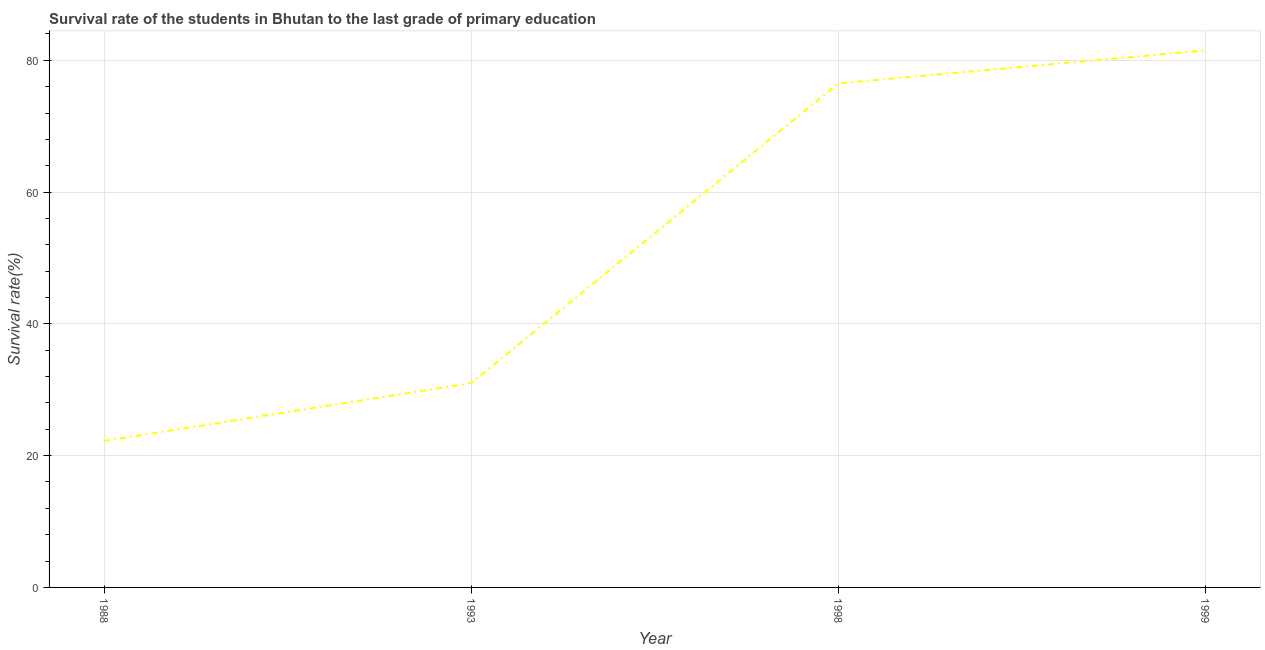What is the survival rate in primary education in 1993?
Your answer should be very brief. 31.02. Across all years, what is the maximum survival rate in primary education?
Your response must be concise. 81.51. Across all years, what is the minimum survival rate in primary education?
Give a very brief answer. 22.22. What is the sum of the survival rate in primary education?
Provide a succinct answer. 211.24. What is the difference between the survival rate in primary education in 1988 and 1998?
Your answer should be very brief. -54.27. What is the average survival rate in primary education per year?
Offer a terse response. 52.81. What is the median survival rate in primary education?
Offer a very short reply. 53.76. In how many years, is the survival rate in primary education greater than 28 %?
Keep it short and to the point. 3. What is the ratio of the survival rate in primary education in 1998 to that in 1999?
Your response must be concise. 0.94. Is the survival rate in primary education in 1988 less than that in 1993?
Offer a terse response. Yes. What is the difference between the highest and the second highest survival rate in primary education?
Provide a succinct answer. 5.01. What is the difference between the highest and the lowest survival rate in primary education?
Offer a very short reply. 59.28. How many lines are there?
Offer a terse response. 1. How many years are there in the graph?
Your answer should be very brief. 4. Are the values on the major ticks of Y-axis written in scientific E-notation?
Make the answer very short. No. Does the graph contain grids?
Provide a succinct answer. Yes. What is the title of the graph?
Provide a short and direct response. Survival rate of the students in Bhutan to the last grade of primary education. What is the label or title of the Y-axis?
Your response must be concise. Survival rate(%). What is the Survival rate(%) of 1988?
Make the answer very short. 22.22. What is the Survival rate(%) in 1993?
Your answer should be very brief. 31.02. What is the Survival rate(%) in 1998?
Your answer should be compact. 76.49. What is the Survival rate(%) in 1999?
Your answer should be very brief. 81.51. What is the difference between the Survival rate(%) in 1988 and 1993?
Keep it short and to the point. -8.79. What is the difference between the Survival rate(%) in 1988 and 1998?
Make the answer very short. -54.27. What is the difference between the Survival rate(%) in 1988 and 1999?
Your answer should be very brief. -59.28. What is the difference between the Survival rate(%) in 1993 and 1998?
Ensure brevity in your answer.  -45.48. What is the difference between the Survival rate(%) in 1993 and 1999?
Your response must be concise. -50.49. What is the difference between the Survival rate(%) in 1998 and 1999?
Give a very brief answer. -5.01. What is the ratio of the Survival rate(%) in 1988 to that in 1993?
Ensure brevity in your answer.  0.72. What is the ratio of the Survival rate(%) in 1988 to that in 1998?
Keep it short and to the point. 0.29. What is the ratio of the Survival rate(%) in 1988 to that in 1999?
Your response must be concise. 0.27. What is the ratio of the Survival rate(%) in 1993 to that in 1998?
Your answer should be compact. 0.41. What is the ratio of the Survival rate(%) in 1993 to that in 1999?
Ensure brevity in your answer.  0.38. What is the ratio of the Survival rate(%) in 1998 to that in 1999?
Give a very brief answer. 0.94. 